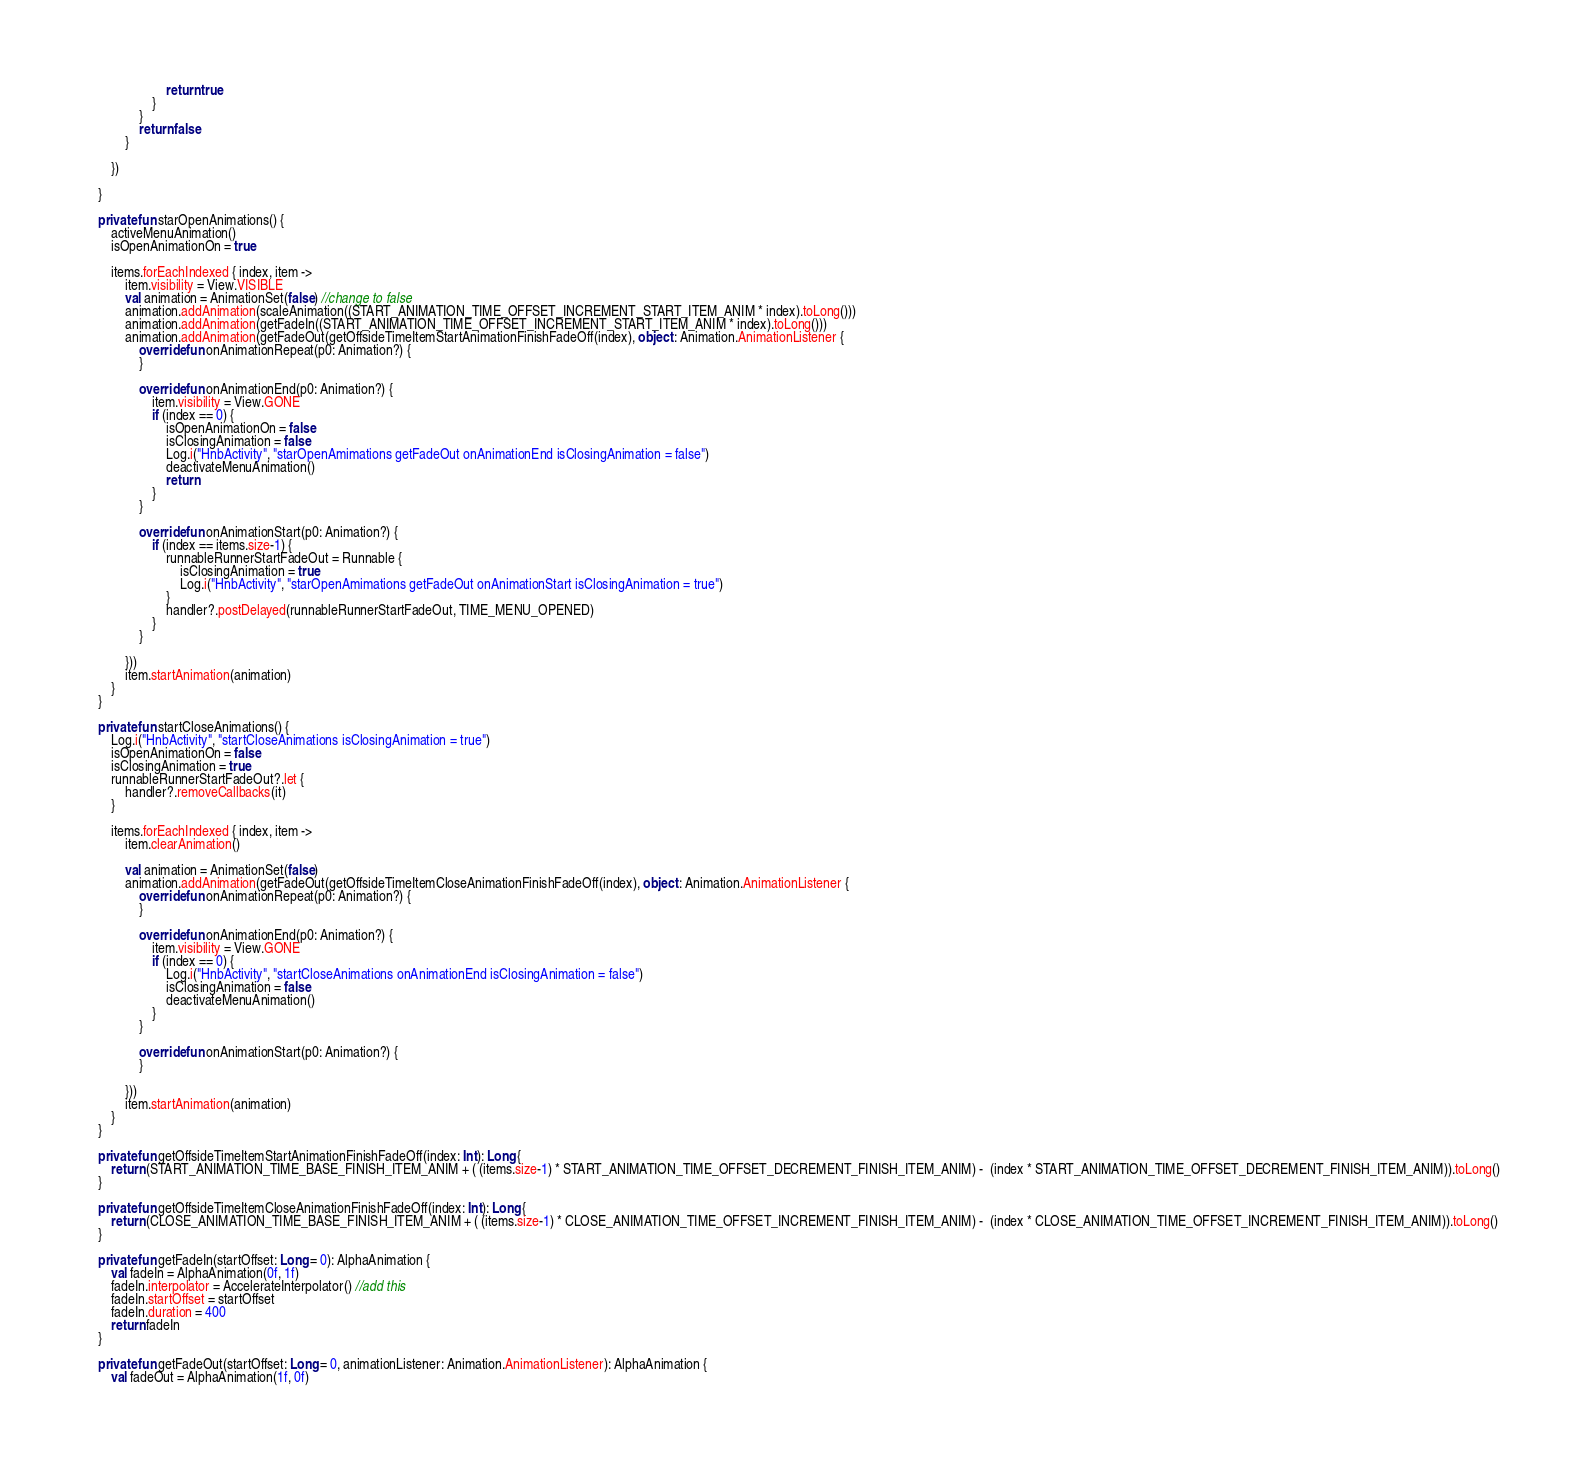Convert code to text. <code><loc_0><loc_0><loc_500><loc_500><_Kotlin_>                        return true
                    }
                }
                return false
            }

        })

    }

    private fun starOpenAnimations() {
        activeMenuAnimation()
        isOpenAnimationOn = true

        items.forEachIndexed { index, item ->
            item.visibility = View.VISIBLE
            val animation = AnimationSet(false) //change to false
            animation.addAnimation(scaleAnimation((START_ANIMATION_TIME_OFFSET_INCREMENT_START_ITEM_ANIM * index).toLong()))
            animation.addAnimation(getFadeIn((START_ANIMATION_TIME_OFFSET_INCREMENT_START_ITEM_ANIM * index).toLong()))
            animation.addAnimation(getFadeOut(getOffsideTimeItemStartAnimationFinishFadeOff(index), object : Animation.AnimationListener {
                override fun onAnimationRepeat(p0: Animation?) {
                }

                override fun onAnimationEnd(p0: Animation?) {
                    item.visibility = View.GONE
                    if (index == 0) {
                        isOpenAnimationOn = false
                        isClosingAnimation = false
                        Log.i("HnbActivity", "starOpenAmimations getFadeOut onAnimationEnd isClosingAnimation = false")
                        deactivateMenuAnimation()
                        return
                    }
                }

                override fun onAnimationStart(p0: Animation?) {
                    if (index == items.size-1) {
                        runnableRunnerStartFadeOut = Runnable {
                            isClosingAnimation = true
                            Log.i("HnbActivity", "starOpenAmimations getFadeOut onAnimationStart isClosingAnimation = true")
                        }
                        handler?.postDelayed(runnableRunnerStartFadeOut, TIME_MENU_OPENED)
                    }
                }

            }))
            item.startAnimation(animation)
        }
    }

    private fun startCloseAnimations() {
        Log.i("HnbActivity", "startCloseAnimations isClosingAnimation = true")
        isOpenAnimationOn = false
        isClosingAnimation = true
        runnableRunnerStartFadeOut?.let {
            handler?.removeCallbacks(it)
        }

        items.forEachIndexed { index, item ->
            item.clearAnimation()

            val animation = AnimationSet(false)
            animation.addAnimation(getFadeOut(getOffsideTimeItemCloseAnimationFinishFadeOff(index), object : Animation.AnimationListener {
                override fun onAnimationRepeat(p0: Animation?) {
                }

                override fun onAnimationEnd(p0: Animation?) {
                    item.visibility = View.GONE
                    if (index == 0) {
                        Log.i("HnbActivity", "startCloseAnimations onAnimationEnd isClosingAnimation = false")
                        isClosingAnimation = false
                        deactivateMenuAnimation()
                    }
                }

                override fun onAnimationStart(p0: Animation?) {
                }

            }))
            item.startAnimation(animation)
        }
    }

    private fun getOffsideTimeItemStartAnimationFinishFadeOff(index: Int): Long {
        return (START_ANIMATION_TIME_BASE_FINISH_ITEM_ANIM + ( (items.size-1) * START_ANIMATION_TIME_OFFSET_DECREMENT_FINISH_ITEM_ANIM) -  (index * START_ANIMATION_TIME_OFFSET_DECREMENT_FINISH_ITEM_ANIM)).toLong()
    }

    private fun getOffsideTimeItemCloseAnimationFinishFadeOff(index: Int): Long {
        return (CLOSE_ANIMATION_TIME_BASE_FINISH_ITEM_ANIM + ( (items.size-1) * CLOSE_ANIMATION_TIME_OFFSET_INCREMENT_FINISH_ITEM_ANIM) -  (index * CLOSE_ANIMATION_TIME_OFFSET_INCREMENT_FINISH_ITEM_ANIM)).toLong()
    }

    private fun getFadeIn(startOffset: Long = 0): AlphaAnimation {
        val fadeIn = AlphaAnimation(0f, 1f)
        fadeIn.interpolator = AccelerateInterpolator() //add this
        fadeIn.startOffset = startOffset
        fadeIn.duration = 400
        return fadeIn
    }

    private fun getFadeOut(startOffset: Long = 0, animationListener: Animation.AnimationListener): AlphaAnimation {
        val fadeOut = AlphaAnimation(1f, 0f)</code> 